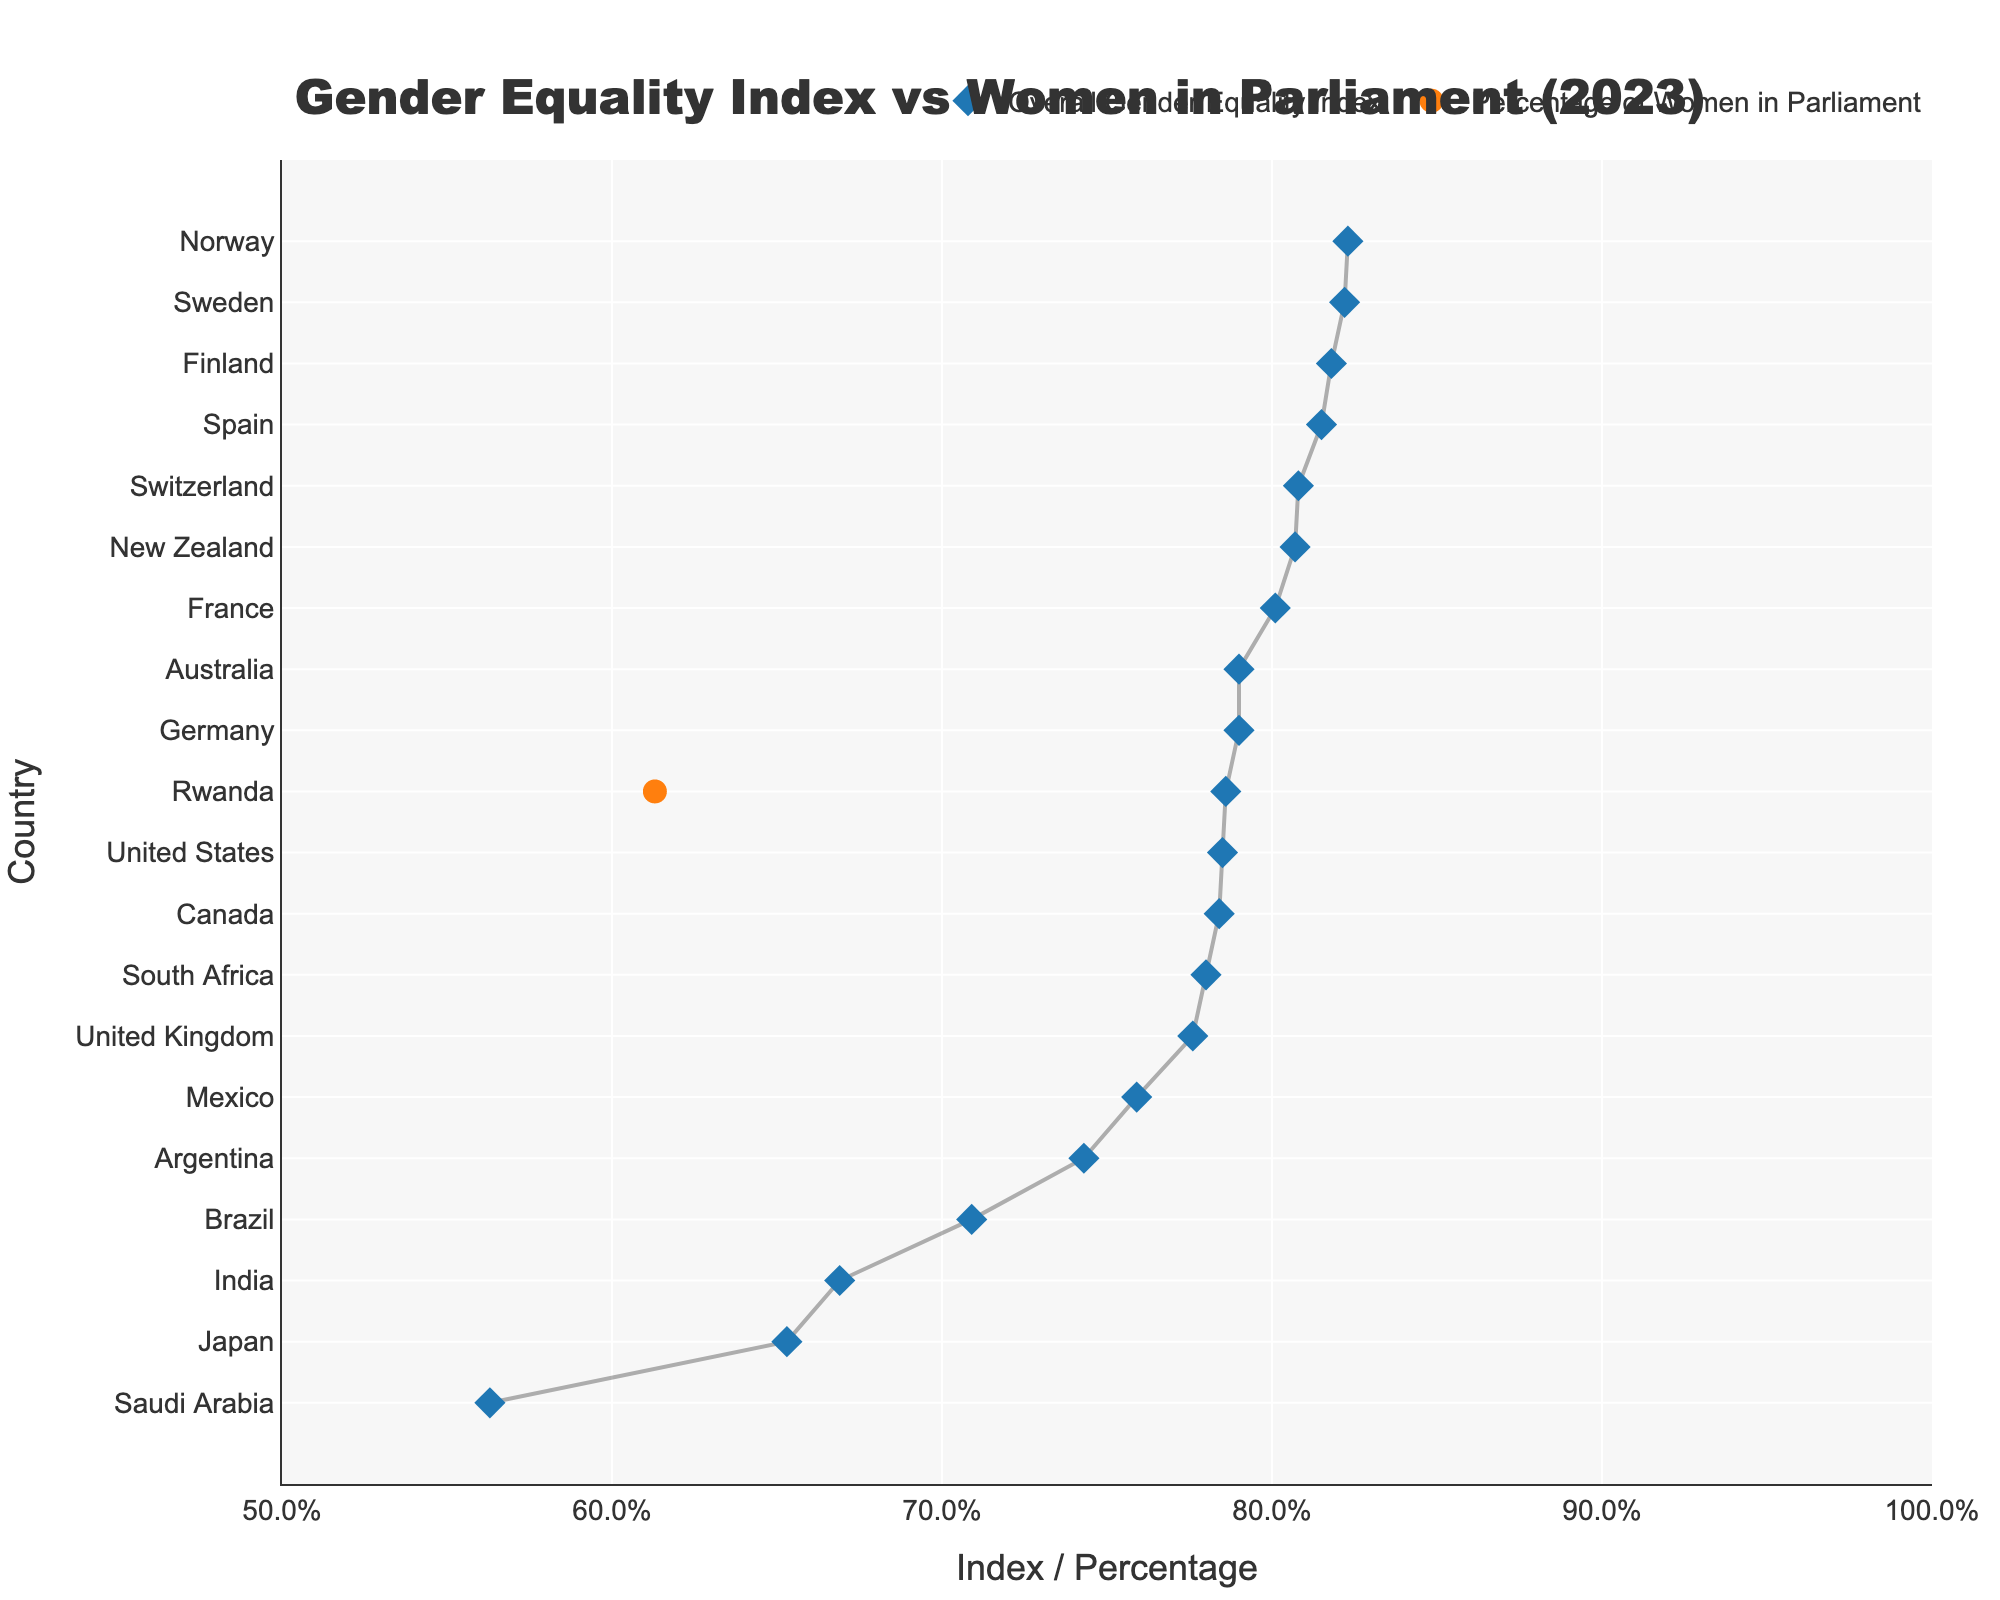Which country has the highest percentage of women in parliament? By identifying the country with the marker color representing Women's parliamentary percentage and noting which marker is furthest to the right, we find Rwanda.
Answer: Rwanda Which country has the lowest Overall Gender Equality Index? By looking for the country at the bottom of the y-axis, which represents the lowest value, we identify Saudi Arabia.
Answer: Saudi Arabia What is the approximate difference between the percentage of women in parliament and the Overall Gender Equality Index in Sweden? Locate Sweden on the y-axis, note the x-axis positions of both markers for Sweden, representing the two values. Subtract the Overall Gender Equality Index (0.822) from the percentage of women in parliament converted to the same scale (0.473). The difference is 0.822 - 0.473 = 0.349.
Answer: 0.349 Which country has a higher proportion of women in parliament than its Overall Gender Equality Index? Compare the two markers for each country to identify the ones where the Women's parliamentary percentage marker is further right than the Gender Equality Index marker. This applies to Rwanda and Mexico.
Answer: Rwanda, Mexico How does the United States compare to South Africa in terms of the Overall Gender Equality Index? Find both countries on the y-axis and compare the positions of the blue markers on the x-axis. South Africa has a slightly lower index (~0.780) compared to the United States (~0.785).
Answer: United States has a higher index What can be inferred about the relationship between the percentage of women in parliament and the Overall Gender Equality Index in Japan? Locate Japan on the y-axis, note the positions of both markers. Japan has a very low percentage of women in parliament (~9.9%) and a low gender equality index (~0.653). The two measures are aligned indicating low scores on both accounts.
Answer: Low on both accounts Which countries have more than 40% of women in parliament? Identify countries whose orange markers are positioned beyond the 0.4 mark on the x-axis. These countries include Sweden, Finland, Norway, Rwanda, New Zealand, Mexico, Spain, Switzerland, and Argentina.
Answer: Sweden, Finland, Norway, Rwanda, New Zealand, Mexico, Spain, Switzerland, Argentina What is the range of the Overall Gender Equality Index among the listed countries? Identify the highest and lowest values for the Overall Gender Equality Index markers on the x-axis, which are for Norway (0.823) and Saudi Arabia (0.563). The range is calculated as 0.823 - 0.563 = 0.26.
Answer: 0.26 What is the difference in the percentage of women in parliament between Finland and Germany? Find the percentage markers for both Finland and Germany on the y-axis and subtract the percentage of Germany (36.7%) from Finland (46.0%). The difference is 46.0% - 36.7% = 9.3%.
Answer: 9.3% 